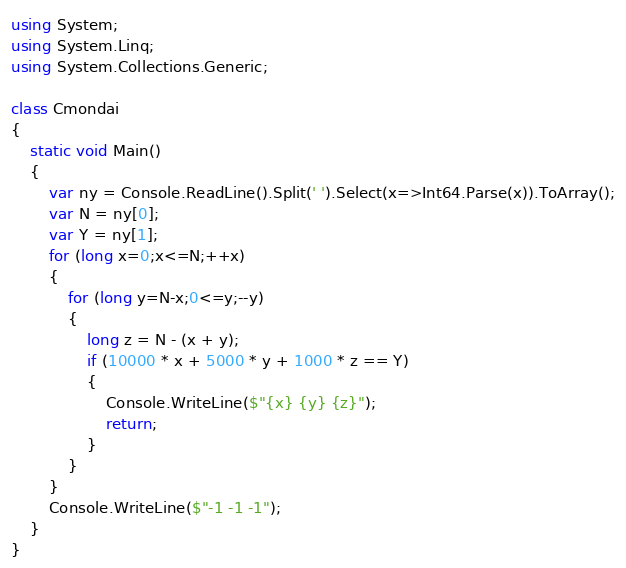<code> <loc_0><loc_0><loc_500><loc_500><_C#_>using System;
using System.Linq;
using System.Collections.Generic;

class Cmondai
{
    static void Main()
    {
        var ny = Console.ReadLine().Split(' ').Select(x=>Int64.Parse(x)).ToArray();
        var N = ny[0];
        var Y = ny[1];
        for (long x=0;x<=N;++x)
        {
            for (long y=N-x;0<=y;--y)
            {
                long z = N - (x + y);
                if (10000 * x + 5000 * y + 1000 * z == Y)
                {
                    Console.WriteLine($"{x} {y} {z}");
                    return;
                }
            }
        }
        Console.WriteLine($"-1 -1 -1");
    }
}</code> 